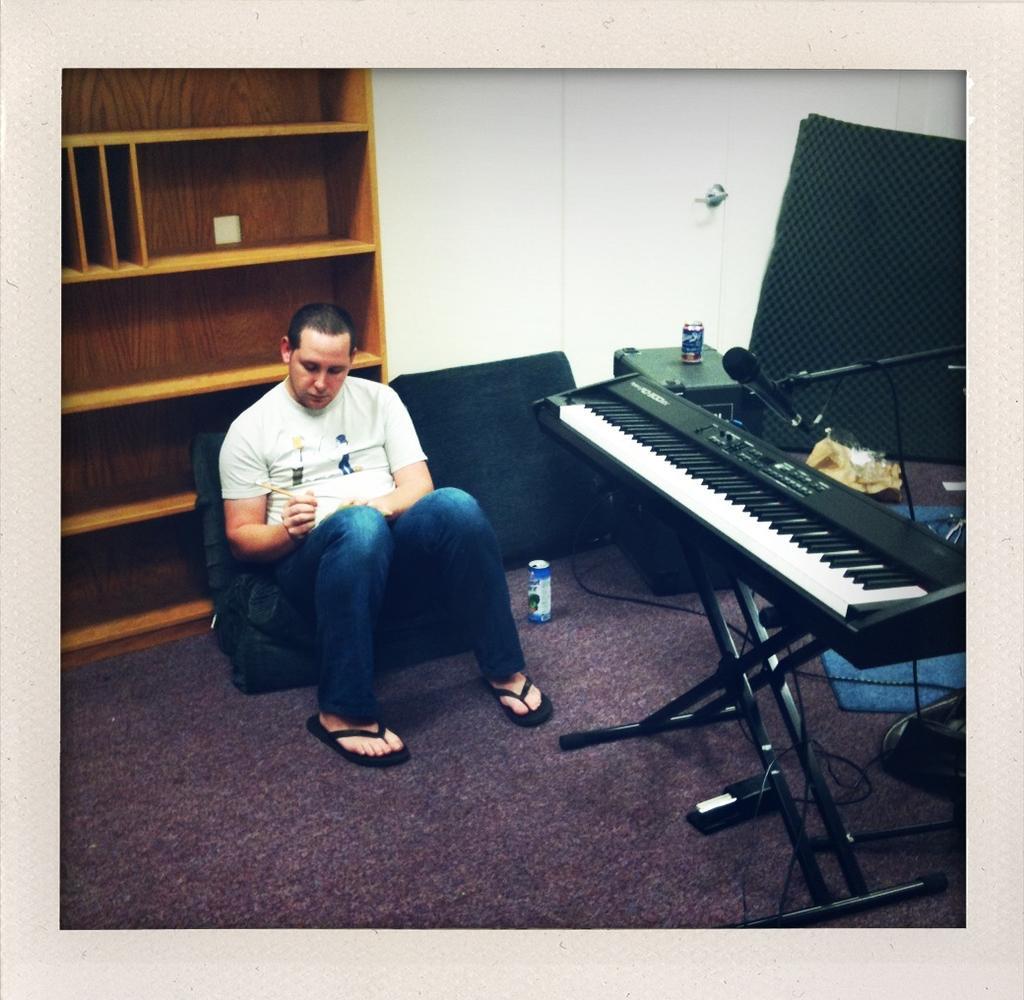How would you summarize this image in a sentence or two? A man is sitting on a bean bag. He is holding a pencil. On the floor there is a can. Behind him there is a wooden cupboard and a wall. In the right corner there is a keyboard with a stand. There is a mic and mic stand. In the corner there is a table. On the table there is a can. 